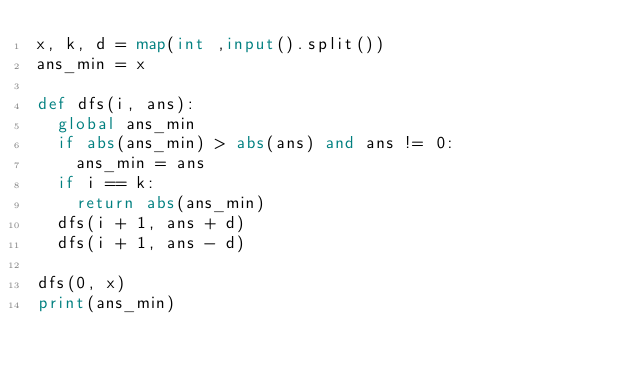<code> <loc_0><loc_0><loc_500><loc_500><_Python_>x, k, d = map(int ,input().split())
ans_min = x

def dfs(i, ans):
  global ans_min
  if abs(ans_min) > abs(ans) and ans != 0:
    ans_min = ans
  if i == k:
    return abs(ans_min)
  dfs(i + 1, ans + d)
  dfs(i + 1, ans - d)

dfs(0, x)
print(ans_min)</code> 